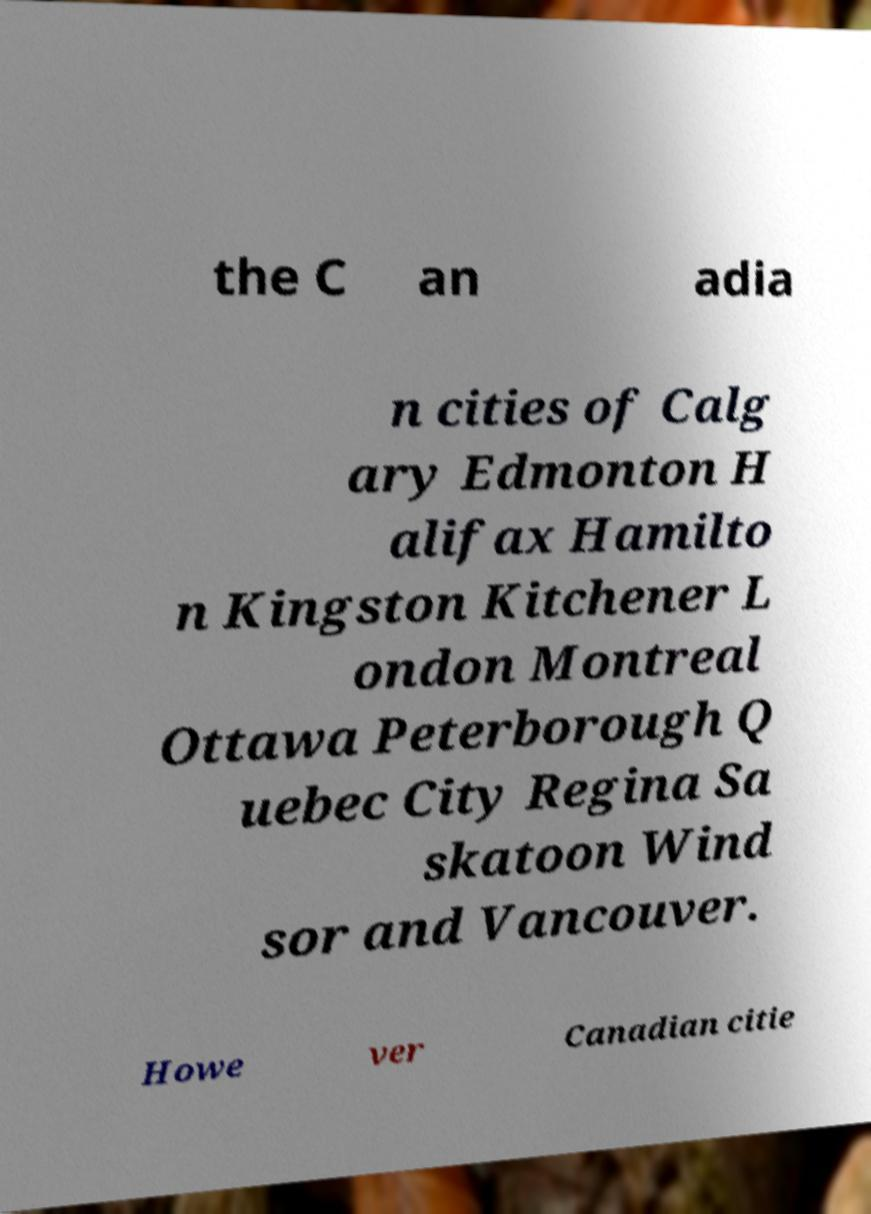Can you accurately transcribe the text from the provided image for me? the C an adia n cities of Calg ary Edmonton H alifax Hamilto n Kingston Kitchener L ondon Montreal Ottawa Peterborough Q uebec City Regina Sa skatoon Wind sor and Vancouver. Howe ver Canadian citie 